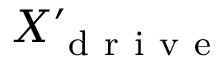Convert formula to latex. <formula><loc_0><loc_0><loc_500><loc_500>X _ { d r i v e } ^ { \prime }</formula> 